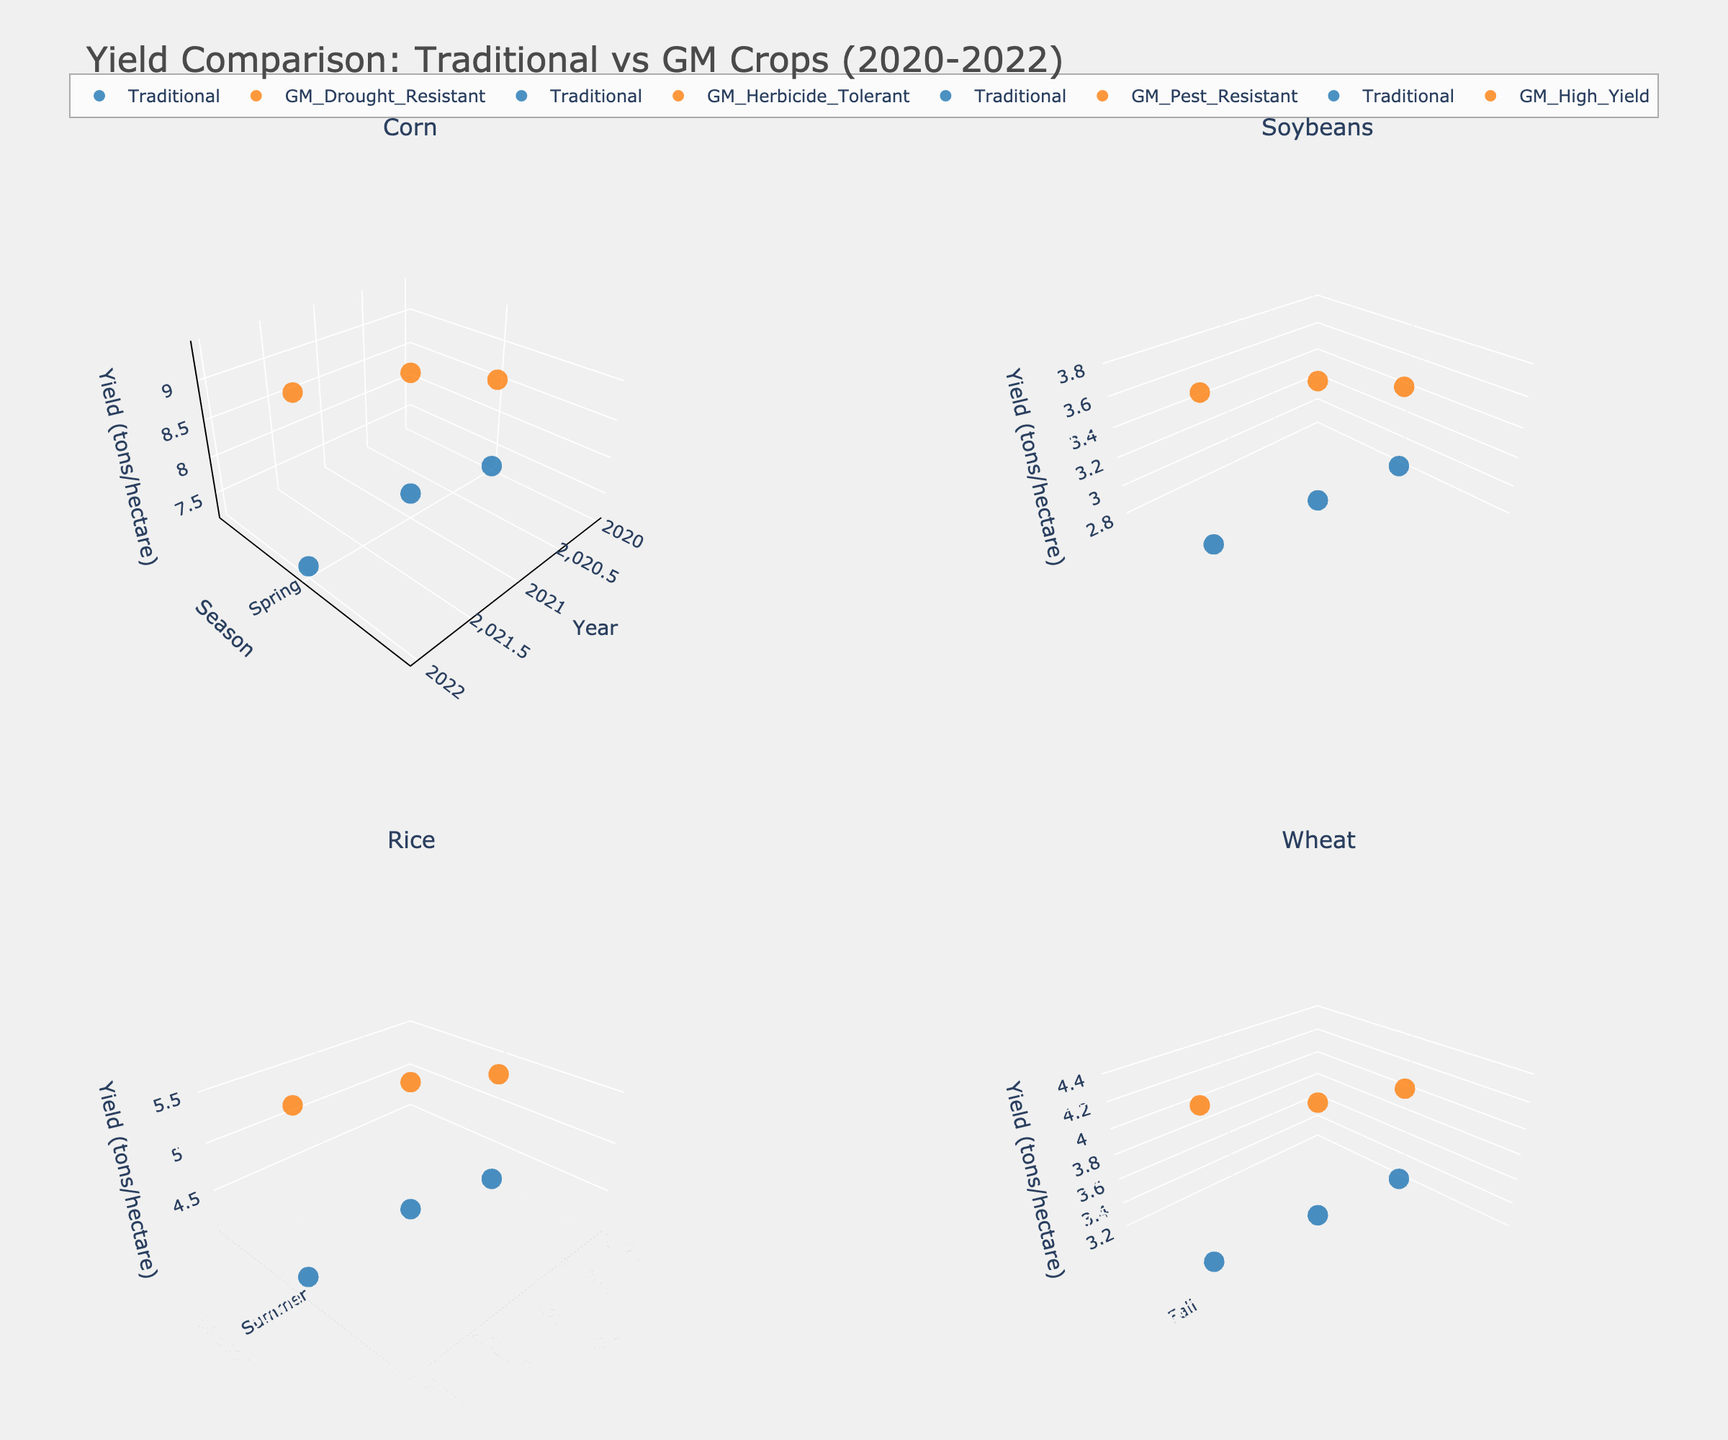What is the title of the figure? The title of the figure is located at the top center and reads "Yield Comparison: Traditional vs GM Crops (2020-2022)"
Answer: Yield Comparison: Traditional vs GM Crops (2020-2022) What are the four types of crops plotted in the subplots? Each subplot is labeled with the type of crop it represents. The titles on the subplots are Corn, Soybeans, Rice, and Wheat.
Answer: Corn, Soybeans, Rice, Wheat Which season shows the highest yield for GM Herbicide-Tolerant Soybeans across all years? We examine the markers in the subplot for Soybeans. For GM Herbicide-Tolerant Soybeans, the marker with the highest yield on the vertical axis (z-axis) is in Spring 2022.
Answer: Spring 2022 In which year and season does traditional Rice have the lowest yield? We look at the subplot for Rice, focusing on the blue markers representing Traditional Rice. The lowest yield on the vertical axis (z-axis) for Traditional Rice is around 4.1, found in Summer 2020.
Answer: Summer 2020 How much higher is the yield of GM Drought-Resistant Corn compared to Traditional Corn in Spring 2021? In the Spring 2021 data for Corn, the yield for GM Drought-Resistant Corn is 9.1 tons/hectare, and for Traditional Corn, it is 7.5 tons/hectare. The difference is 9.1 - 7.5 = 1.6 tons/hectare.
Answer: 1.6 tons/hectare Which crop shows the greatest yield improvement in GM versus Traditional methods across the years? We need to compare the yield improvements in each subplot. GM Drought-Resistant Corn shows consistent improvements greater than 2 tons/hectare compared to Traditional Corn in all years, which is the highest amongst all the crops.
Answer: GM Drought-Resistant Corn What is the average yield of GM High-Yield Wheat across the three years? For Wheat, the GM High-Yield yields in Fall 2020, Fall 2021, and Fall 2022 are 4.0, 4.2, and 4.5 tons/hectare, respectively. The average is (4.0 + 4.2 + 4.5) / 3 = 4.23 tons/hectare.
Answer: 4.23 tons/hectare Which GM crop has the highest single yield value over the three-year period? By examining all subplots for GM crops, GM Drought-Resistant Corn has the highest single yield value with 9.4 tons/hectare in Spring 2022.
Answer: GM Drought-Resistant Corn in Spring 2022 